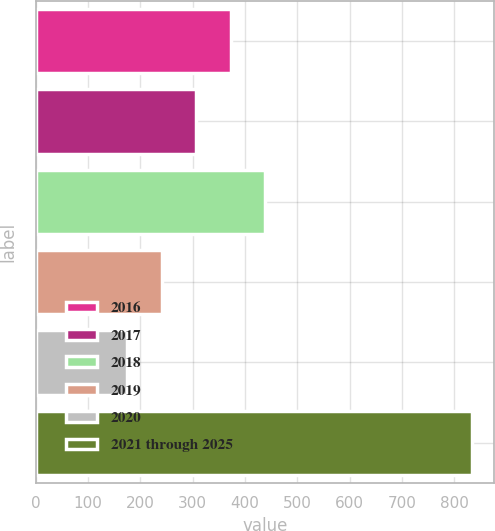Convert chart to OTSL. <chart><loc_0><loc_0><loc_500><loc_500><bar_chart><fcel>2016<fcel>2017<fcel>2018<fcel>2019<fcel>2020<fcel>2021 through 2025<nl><fcel>372.7<fcel>306.8<fcel>438.6<fcel>240.9<fcel>175<fcel>834<nl></chart> 